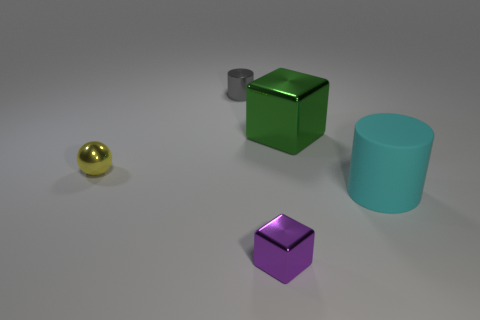Are there the same number of large cyan rubber cylinders behind the big cyan cylinder and tiny purple shiny things?
Your answer should be compact. No. There is a thing that is both behind the yellow metal ball and right of the gray shiny object; what material is it?
Your response must be concise. Metal. Are there any gray cylinders that are to the left of the cube that is in front of the cyan object?
Ensure brevity in your answer.  Yes. Does the tiny cylinder have the same material as the green object?
Provide a succinct answer. Yes. There is a object that is both in front of the green metallic block and to the right of the tiny block; what shape is it?
Your response must be concise. Cylinder. What is the size of the shiny thing that is in front of the tiny shiny object to the left of the tiny metal cylinder?
Offer a terse response. Small. How many other gray shiny things have the same shape as the gray object?
Keep it short and to the point. 0. Is there anything else that is the same shape as the yellow metal object?
Your answer should be very brief. No. Do the tiny object that is right of the gray thing and the thing left of the tiny cylinder have the same material?
Give a very brief answer. Yes. The tiny ball has what color?
Offer a terse response. Yellow. 